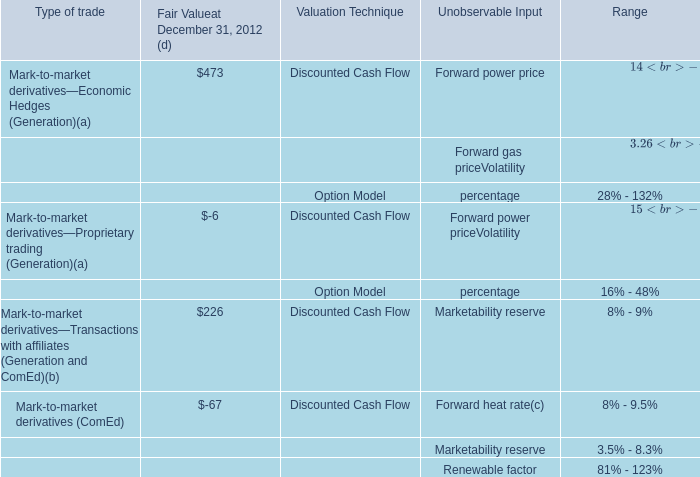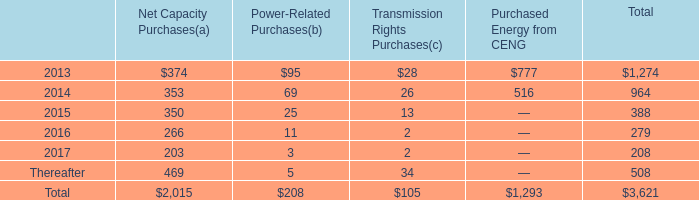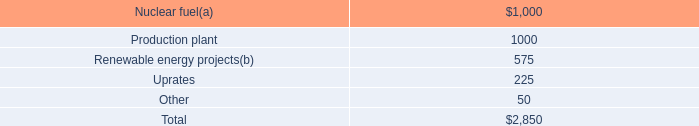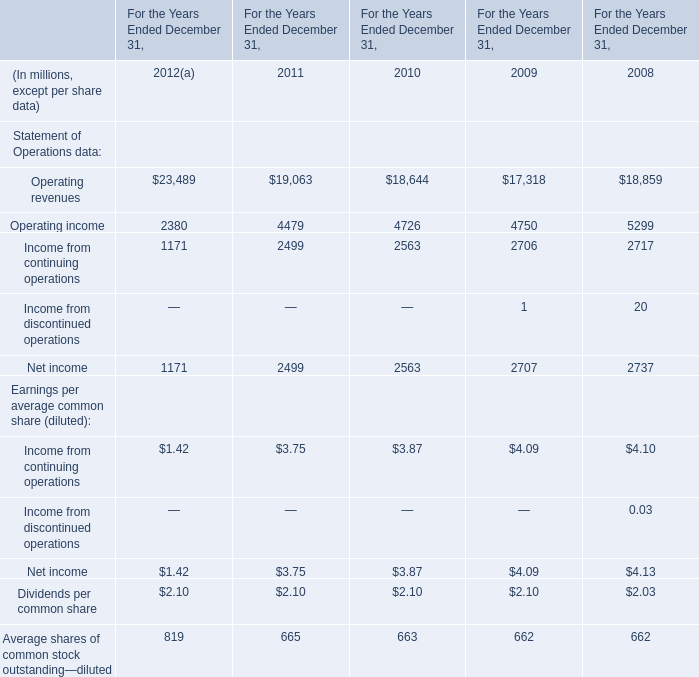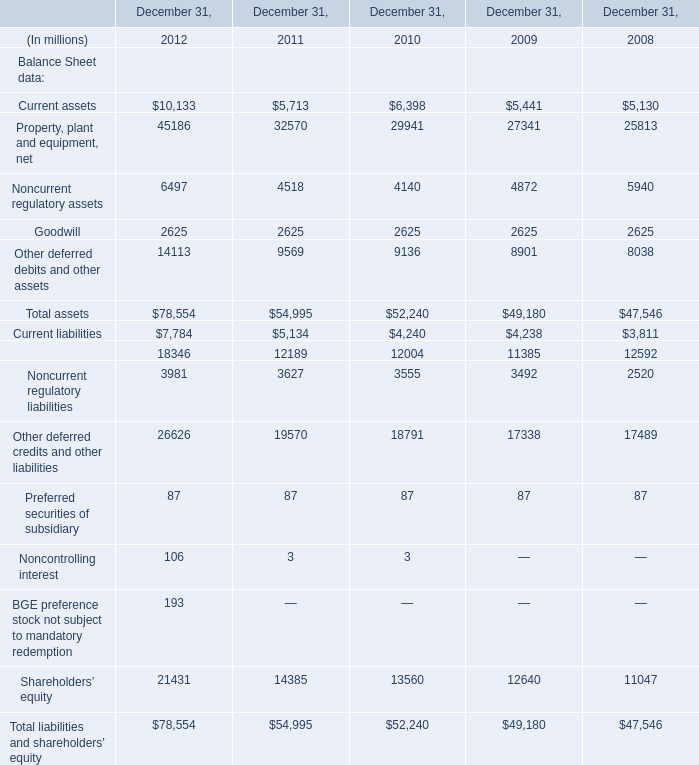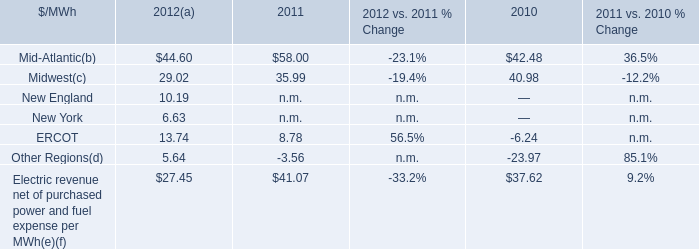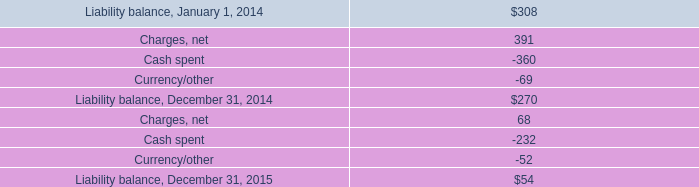what's the total amount of Operating income of For the Years Ended December 31, 2009, and Current assets of December 31, 2008 ? 
Computations: (4750.0 + 5130.0)
Answer: 9880.0. 